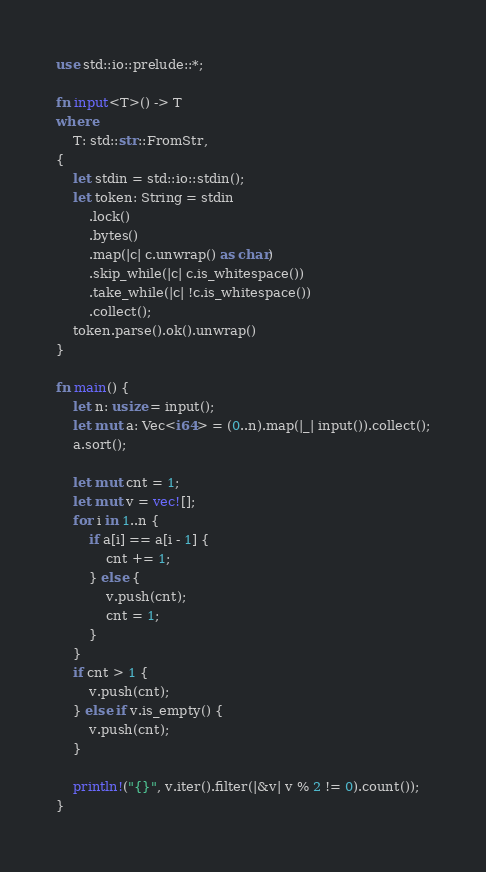Convert code to text. <code><loc_0><loc_0><loc_500><loc_500><_Rust_>use std::io::prelude::*;

fn input<T>() -> T
where
    T: std::str::FromStr,
{
    let stdin = std::io::stdin();
    let token: String = stdin
        .lock()
        .bytes()
        .map(|c| c.unwrap() as char)
        .skip_while(|c| c.is_whitespace())
        .take_while(|c| !c.is_whitespace())
        .collect();
    token.parse().ok().unwrap()
}

fn main() {
    let n: usize = input();
    let mut a: Vec<i64> = (0..n).map(|_| input()).collect();
    a.sort();

    let mut cnt = 1;
    let mut v = vec![];
    for i in 1..n {
        if a[i] == a[i - 1] {
            cnt += 1;
        } else {
            v.push(cnt);
            cnt = 1;
        }
    }
    if cnt > 1 {
        v.push(cnt);
    } else if v.is_empty() {
        v.push(cnt);
    }

    println!("{}", v.iter().filter(|&v| v % 2 != 0).count());
}
</code> 